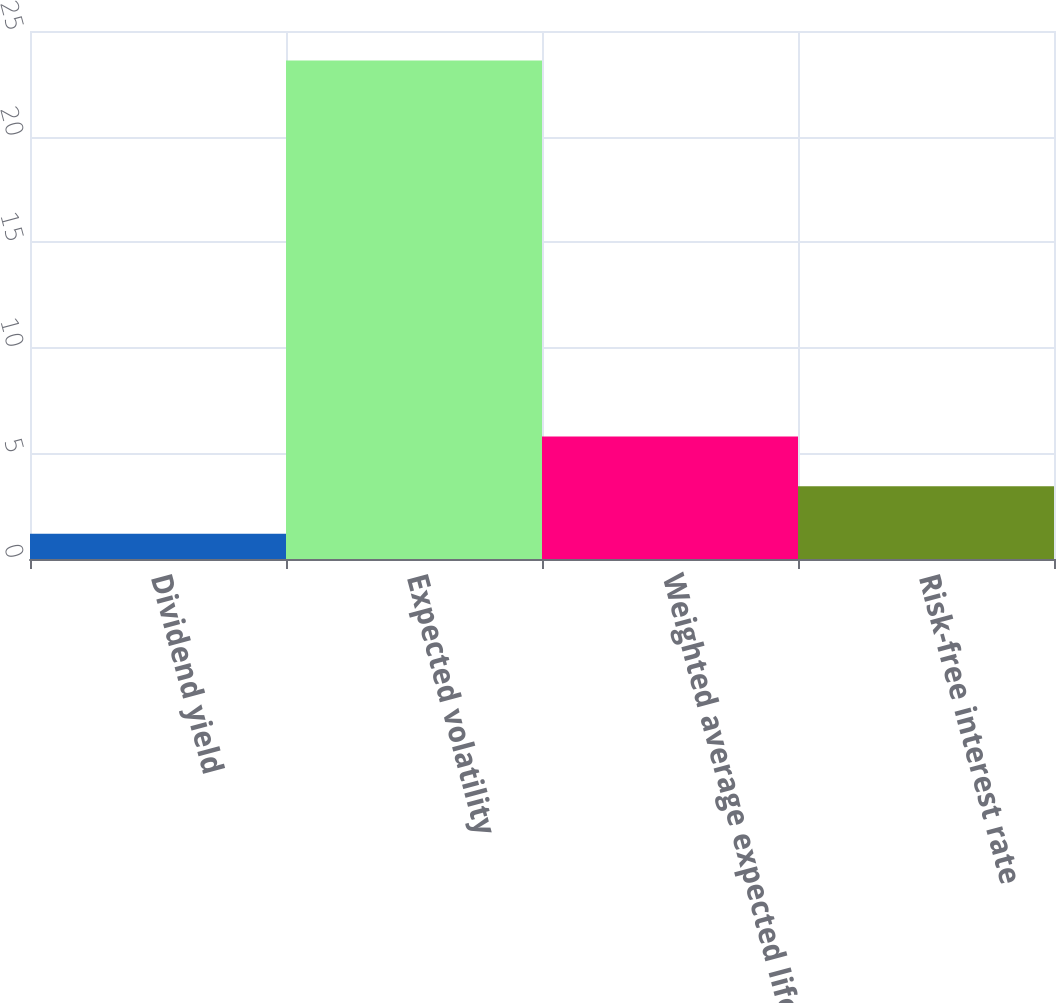<chart> <loc_0><loc_0><loc_500><loc_500><bar_chart><fcel>Dividend yield<fcel>Expected volatility<fcel>Weighted average expected life<fcel>Risk-free interest rate<nl><fcel>1.2<fcel>23.6<fcel>5.8<fcel>3.44<nl></chart> 